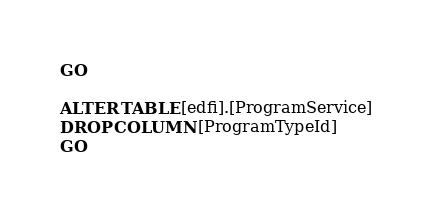<code> <loc_0><loc_0><loc_500><loc_500><_SQL_>GO

ALTER TABLE [edfi].[ProgramService]
DROP COLUMN [ProgramTypeId]
GO

</code> 